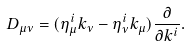<formula> <loc_0><loc_0><loc_500><loc_500>D _ { \mu \nu } = ( \eta _ { \mu } ^ { i } k _ { \nu } - \eta _ { \nu } ^ { i } k _ { \mu } ) \frac { \partial } { \partial k ^ { i } } .</formula> 